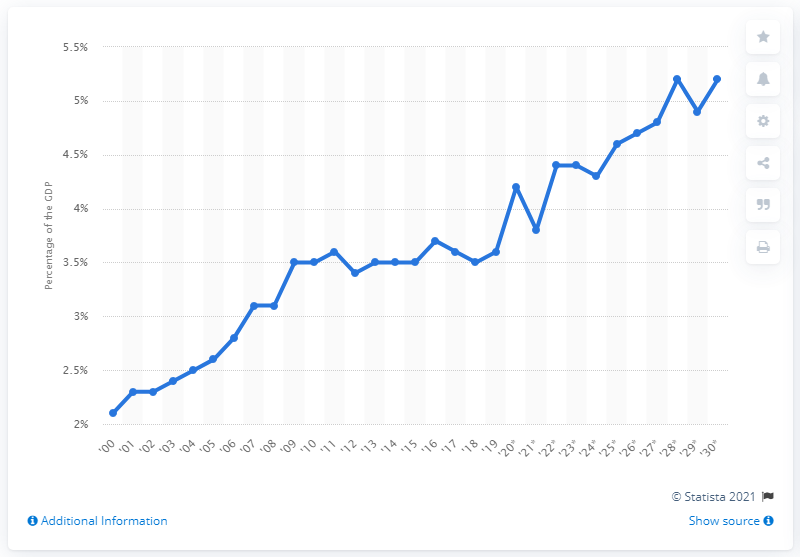Specify some key components in this picture. Medicare outlays are expected to increase by 3.6% in 2030. In 2018, Medicare outlays accounted for approximately 3.6% of the total Gross Domestic Product (GDP) of the United States. 